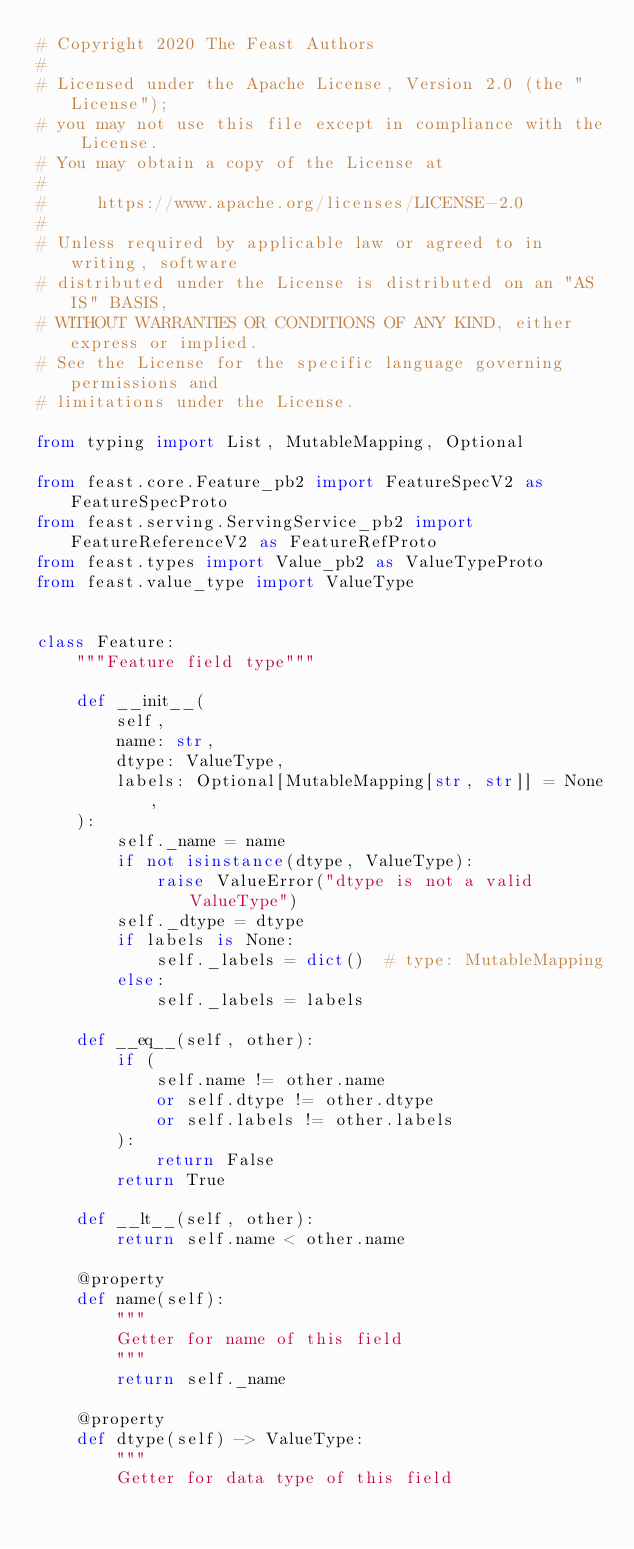Convert code to text. <code><loc_0><loc_0><loc_500><loc_500><_Python_># Copyright 2020 The Feast Authors
#
# Licensed under the Apache License, Version 2.0 (the "License");
# you may not use this file except in compliance with the License.
# You may obtain a copy of the License at
#
#     https://www.apache.org/licenses/LICENSE-2.0
#
# Unless required by applicable law or agreed to in writing, software
# distributed under the License is distributed on an "AS IS" BASIS,
# WITHOUT WARRANTIES OR CONDITIONS OF ANY KIND, either express or implied.
# See the License for the specific language governing permissions and
# limitations under the License.

from typing import List, MutableMapping, Optional

from feast.core.Feature_pb2 import FeatureSpecV2 as FeatureSpecProto
from feast.serving.ServingService_pb2 import FeatureReferenceV2 as FeatureRefProto
from feast.types import Value_pb2 as ValueTypeProto
from feast.value_type import ValueType


class Feature:
    """Feature field type"""

    def __init__(
        self,
        name: str,
        dtype: ValueType,
        labels: Optional[MutableMapping[str, str]] = None,
    ):
        self._name = name
        if not isinstance(dtype, ValueType):
            raise ValueError("dtype is not a valid ValueType")
        self._dtype = dtype
        if labels is None:
            self._labels = dict()  # type: MutableMapping
        else:
            self._labels = labels

    def __eq__(self, other):
        if (
            self.name != other.name
            or self.dtype != other.dtype
            or self.labels != other.labels
        ):
            return False
        return True

    def __lt__(self, other):
        return self.name < other.name

    @property
    def name(self):
        """
        Getter for name of this field
        """
        return self._name

    @property
    def dtype(self) -> ValueType:
        """
        Getter for data type of this field</code> 